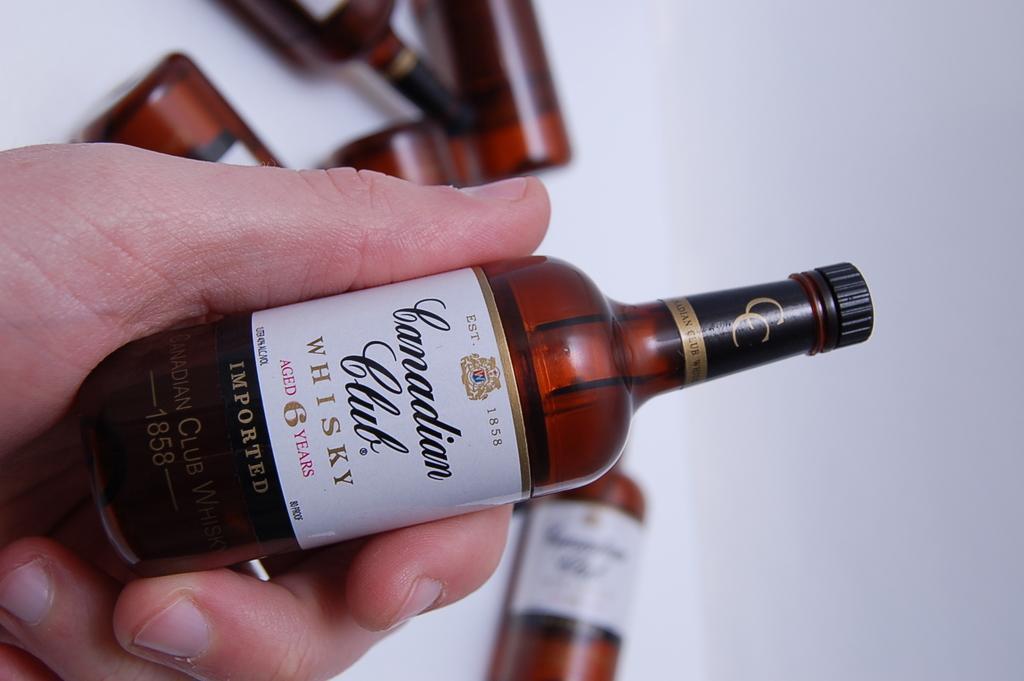How would you summarize this image in a sentence or two? In this picture I can see there is a person holding a small bottle in his hand and in the backdrop there is a white surface and there are many more bottles. 